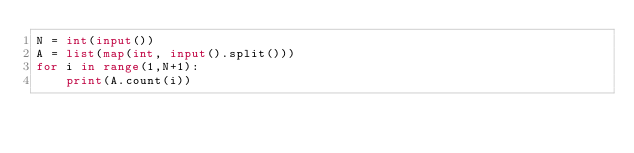Convert code to text. <code><loc_0><loc_0><loc_500><loc_500><_Python_>N = int(input())
A = list(map(int, input().split()))
for i in range(1,N+1):
    print(A.count(i))</code> 